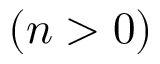Convert formula to latex. <formula><loc_0><loc_0><loc_500><loc_500>( n > 0 )</formula> 